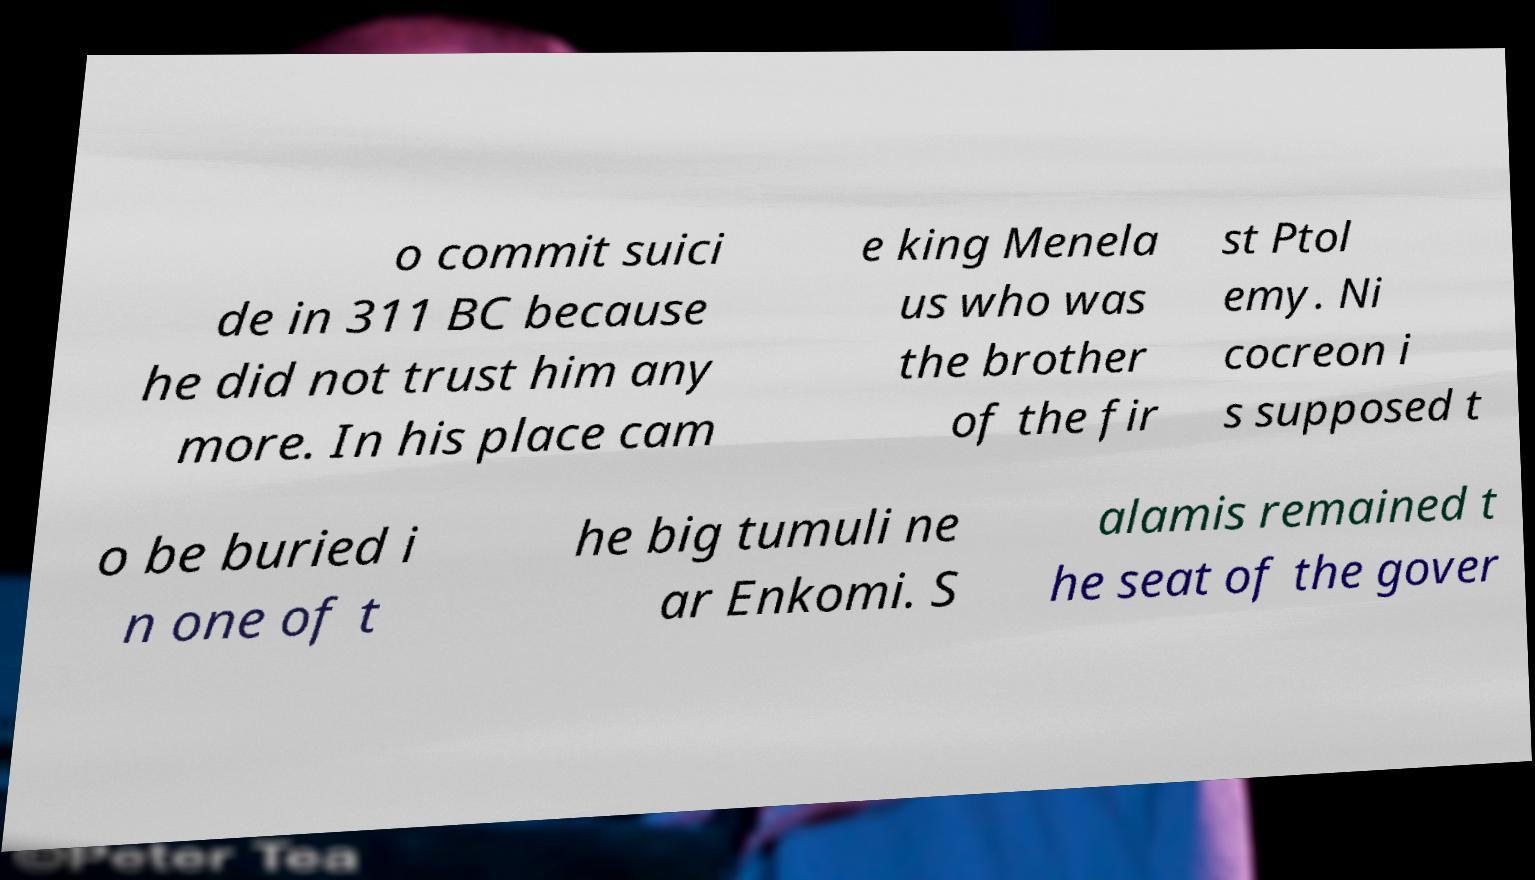Please identify and transcribe the text found in this image. o commit suici de in 311 BC because he did not trust him any more. In his place cam e king Menela us who was the brother of the fir st Ptol emy. Ni cocreon i s supposed t o be buried i n one of t he big tumuli ne ar Enkomi. S alamis remained t he seat of the gover 